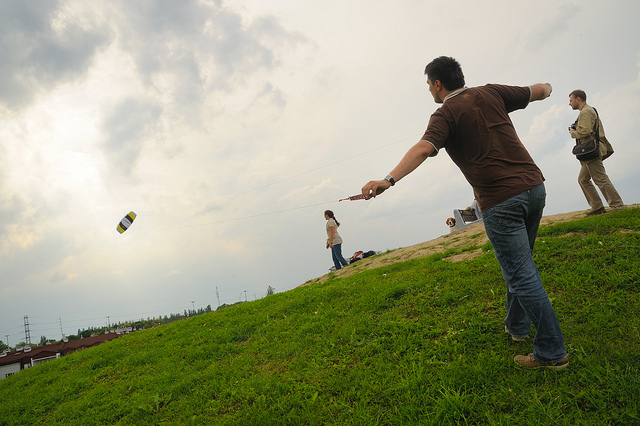What activity is the person in the foreground doing? The person in the foreground seems to be flying a kite or similar apparatus, which is captured mid-air, demonstrating their control over it. 